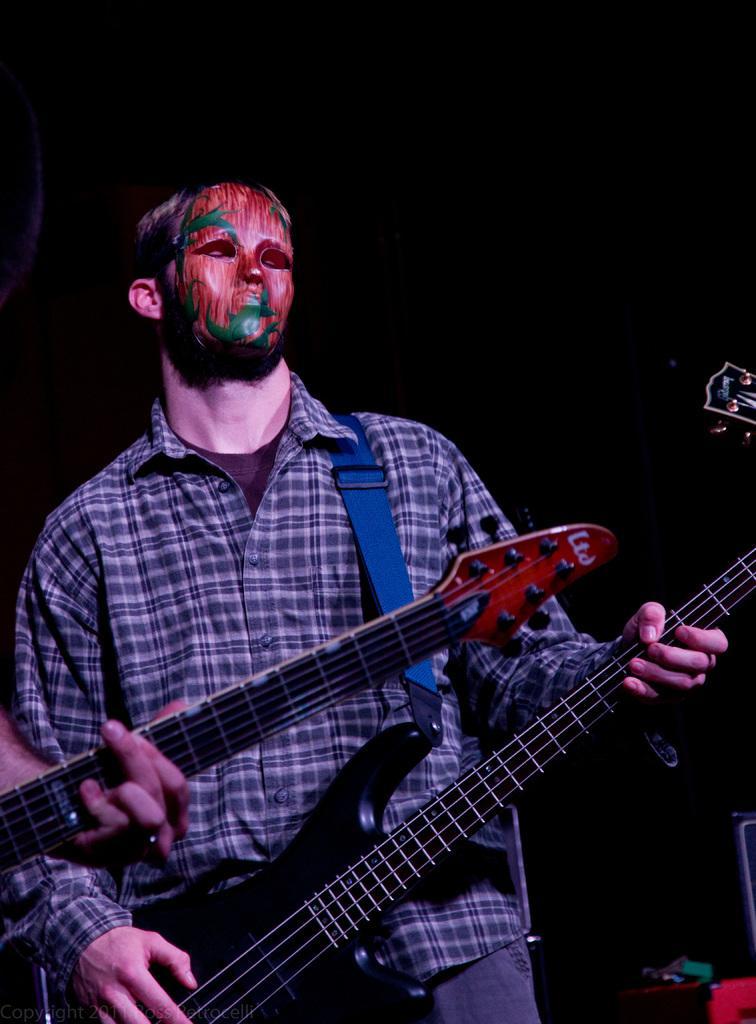Can you describe this image briefly? In this image there is a man standing and playing a guitar , another person standing and playing a guitar. 